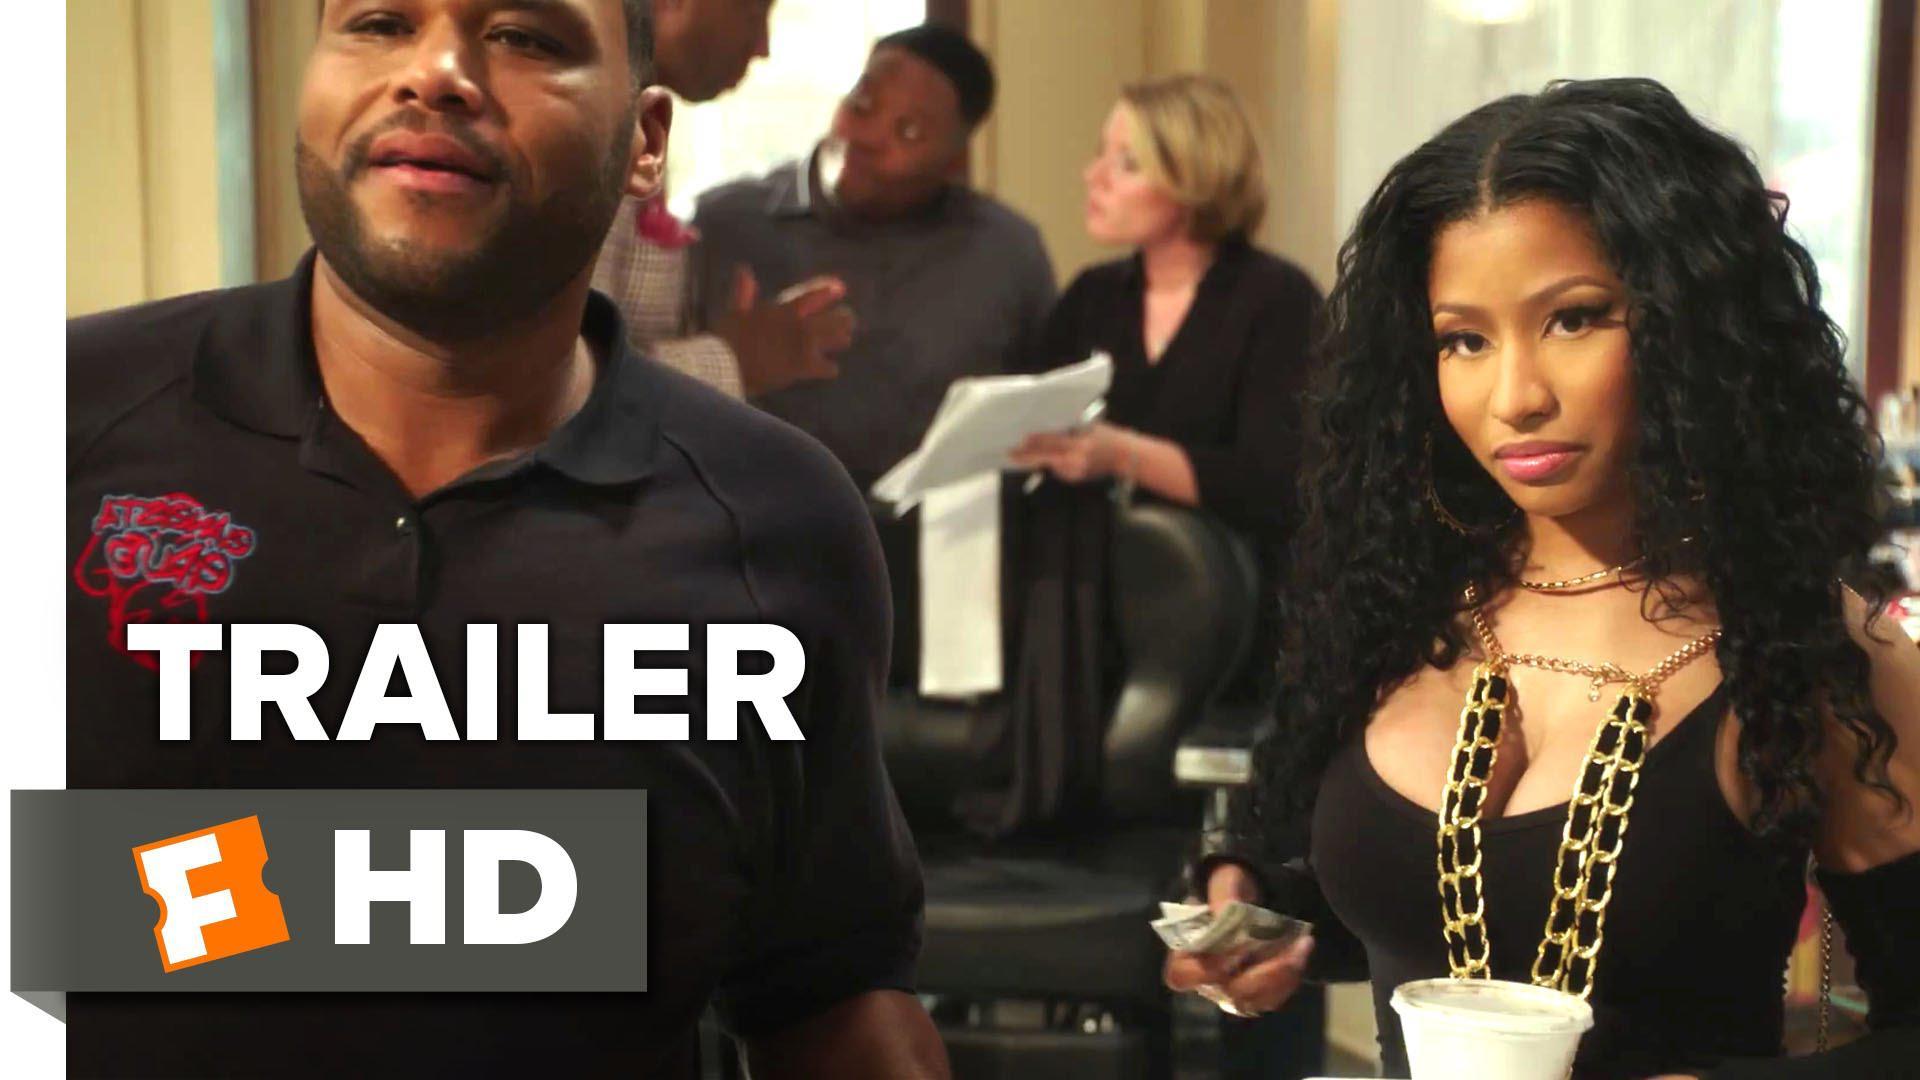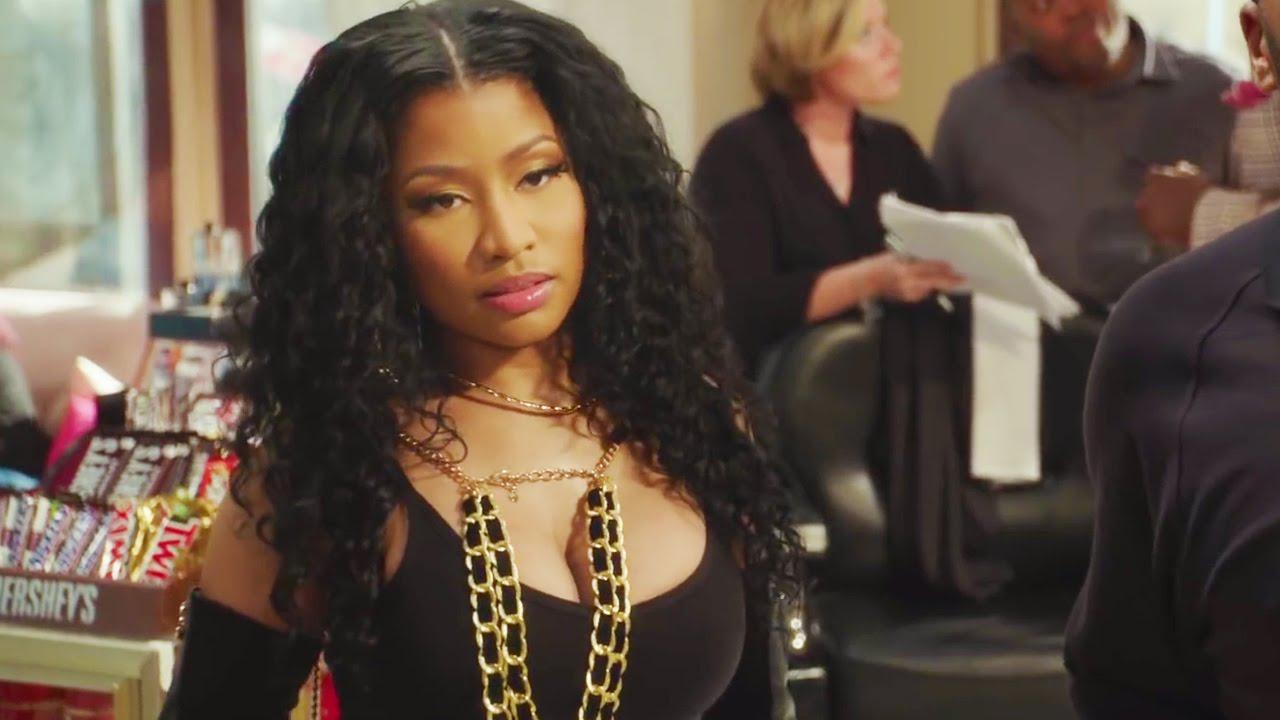The first image is the image on the left, the second image is the image on the right. Assess this claim about the two images: "Nikki  Ménage is dressed in gold and black with a single short blond hair and woman in the background.". Correct or not? Answer yes or no. Yes. The first image is the image on the left, the second image is the image on the right. Evaluate the accuracy of this statement regarding the images: "Nikki Minaj is NOT in the image on the right.". Is it true? Answer yes or no. No. 